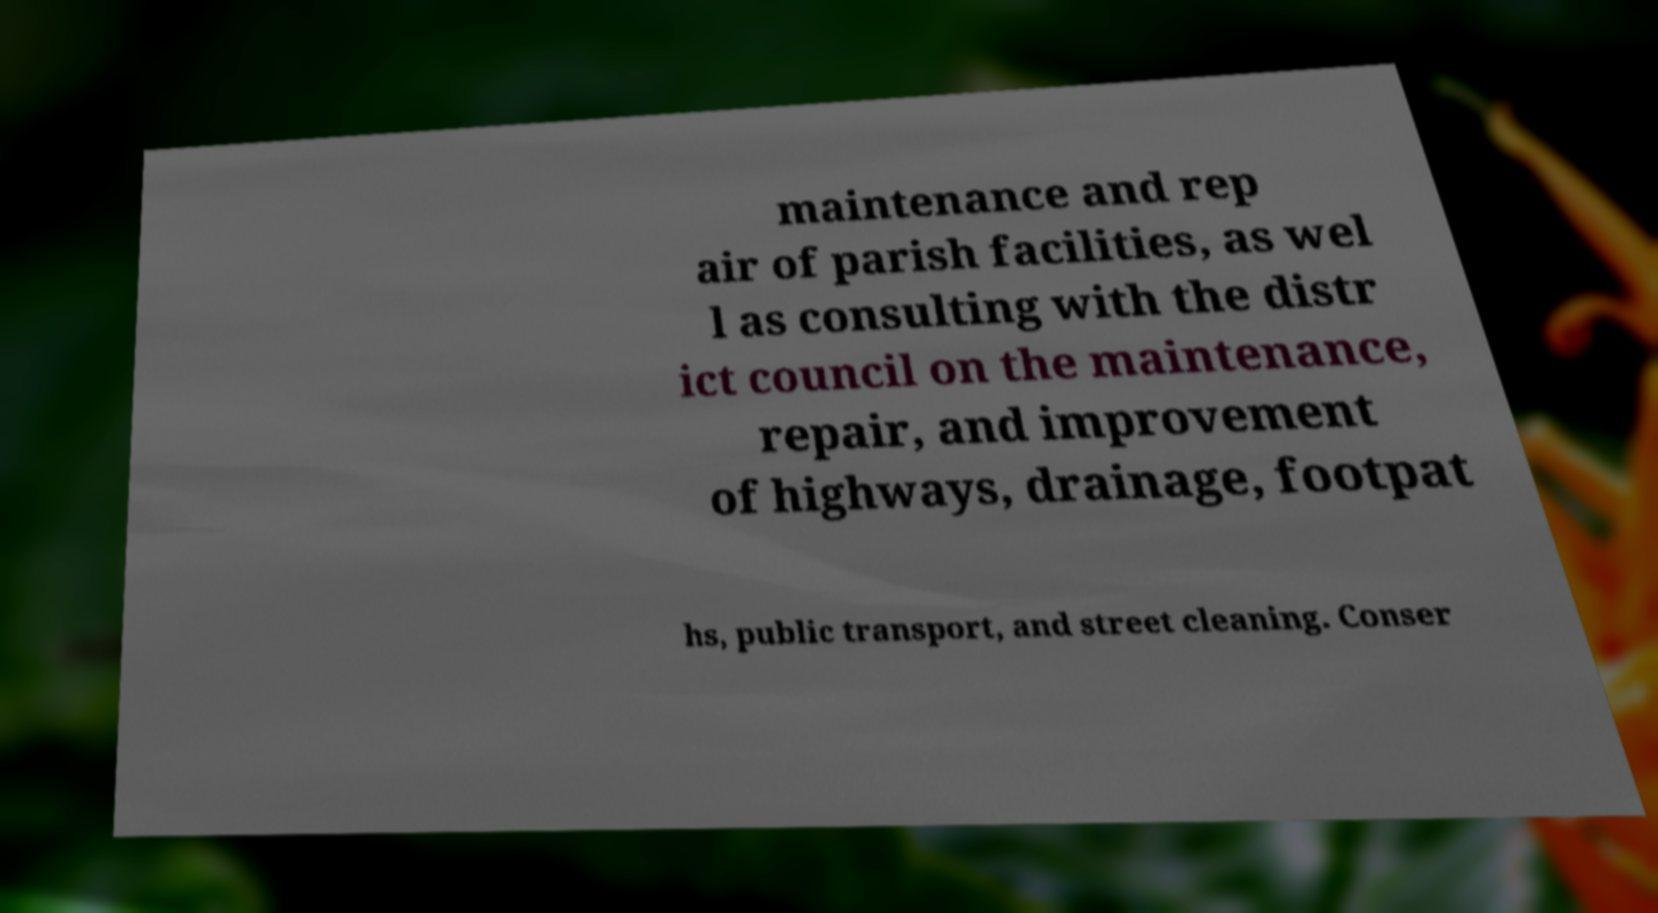Could you extract and type out the text from this image? maintenance and rep air of parish facilities, as wel l as consulting with the distr ict council on the maintenance, repair, and improvement of highways, drainage, footpat hs, public transport, and street cleaning. Conser 